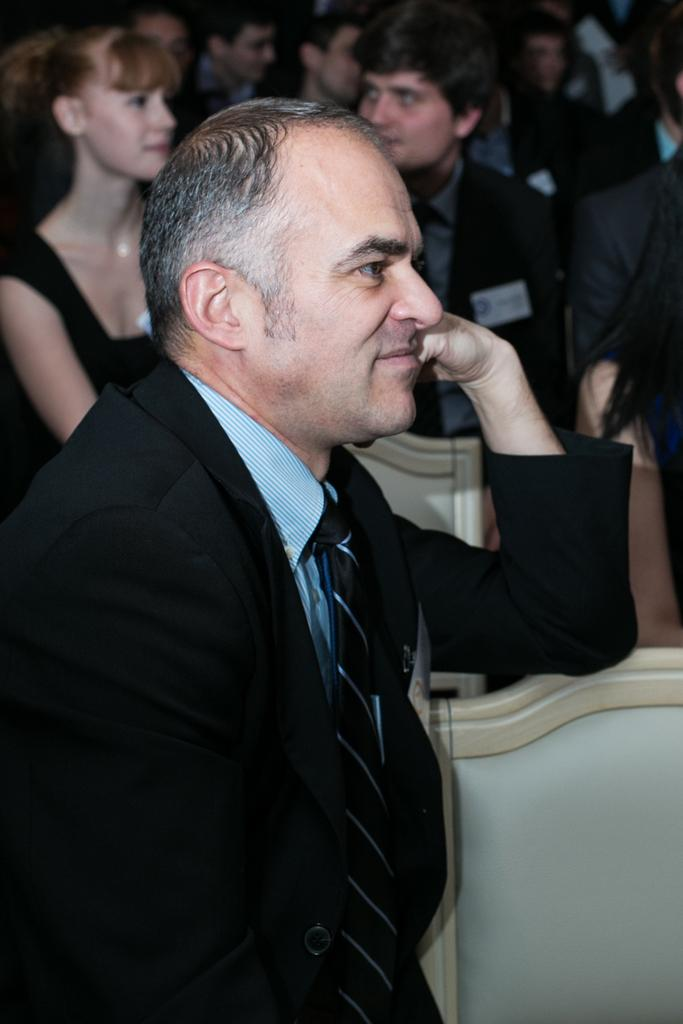What is the man in the foreground of the image wearing? The man in the foreground is wearing a coat. What can be seen in the background of the image? There are men and women in the background of the image. Can you describe the attire of one of the women in the background? Yes, one of the women in the background is wearing a black dress. What is the owner of the birthday party thinking in the image? There is no information about a birthday party or an owner in the image, so it is not possible to answer this question. 